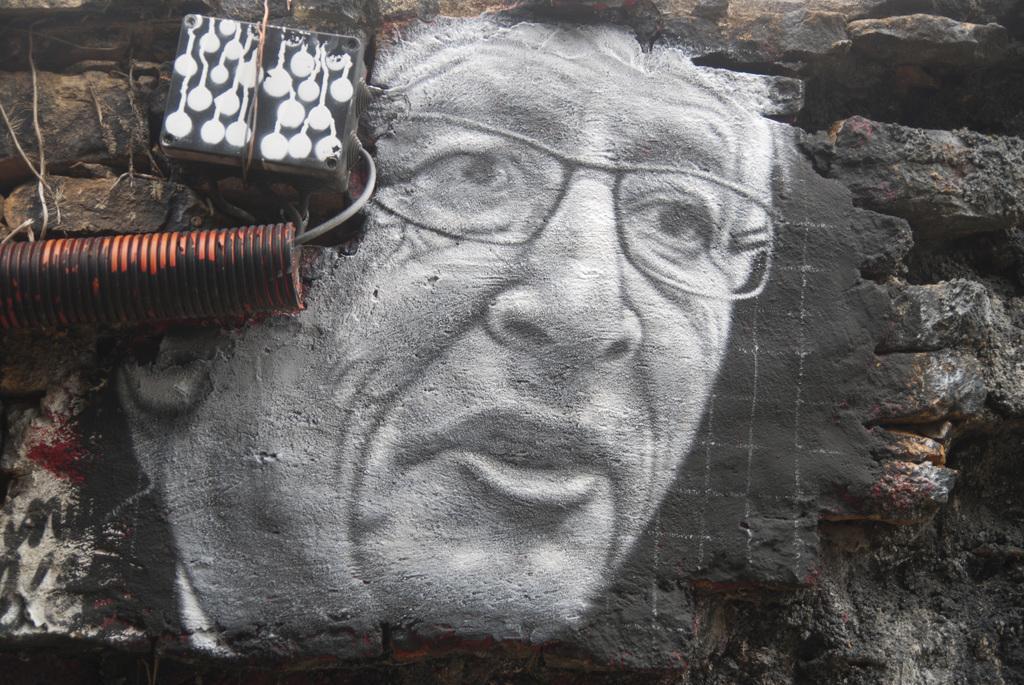Can you describe this image briefly? In this picture we can see an art on the wall, on the left side of the image we can see a pipe and a cable. 